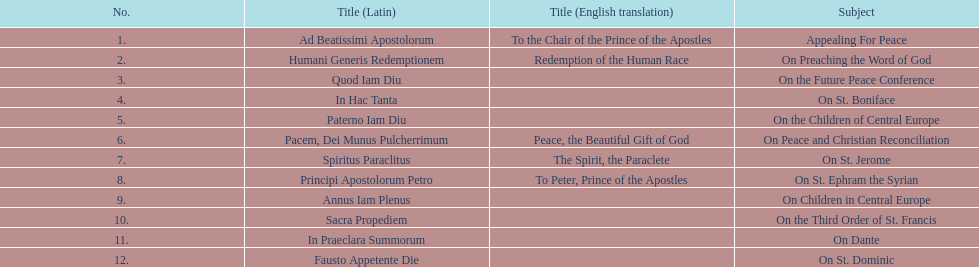In the table, what is the earliest english translation listed? To the Chair of the Prince of the Apostles. 